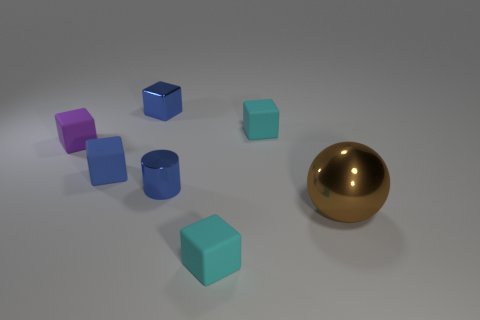Subtract all tiny blue metal cubes. How many cubes are left? 4 Subtract all purple blocks. How many blocks are left? 4 Subtract all blue blocks. Subtract all gray cylinders. How many blocks are left? 3 Add 3 small cylinders. How many objects exist? 10 Subtract all balls. How many objects are left? 6 Subtract 0 red balls. How many objects are left? 7 Subtract all metal blocks. Subtract all metallic objects. How many objects are left? 3 Add 6 blue matte cubes. How many blue matte cubes are left? 7 Add 3 big brown metal things. How many big brown metal things exist? 4 